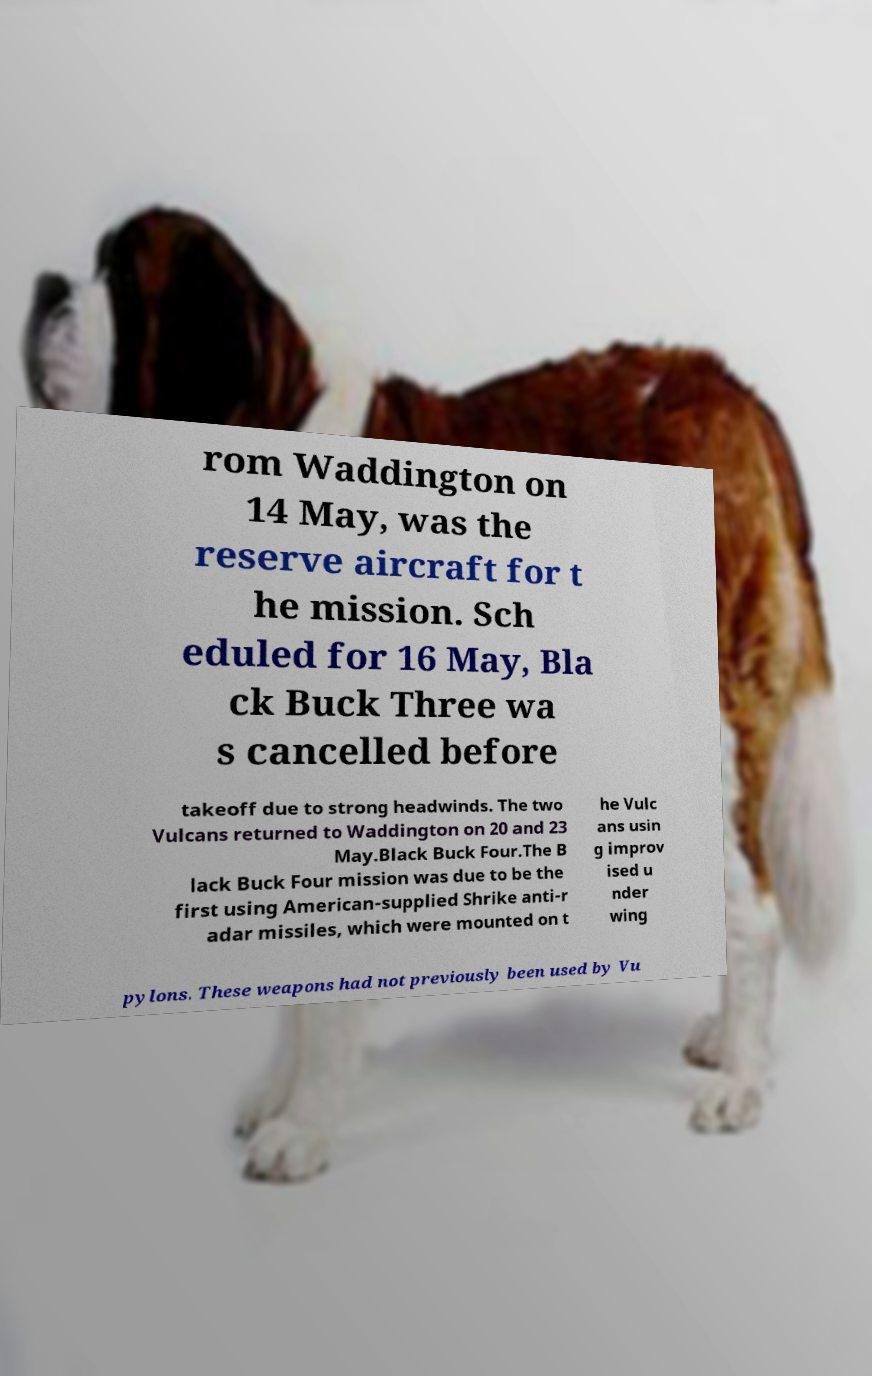Please identify and transcribe the text found in this image. rom Waddington on 14 May, was the reserve aircraft for t he mission. Sch eduled for 16 May, Bla ck Buck Three wa s cancelled before takeoff due to strong headwinds. The two Vulcans returned to Waddington on 20 and 23 May.Black Buck Four.The B lack Buck Four mission was due to be the first using American-supplied Shrike anti-r adar missiles, which were mounted on t he Vulc ans usin g improv ised u nder wing pylons. These weapons had not previously been used by Vu 